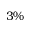<formula> <loc_0><loc_0><loc_500><loc_500>3 \%</formula> 